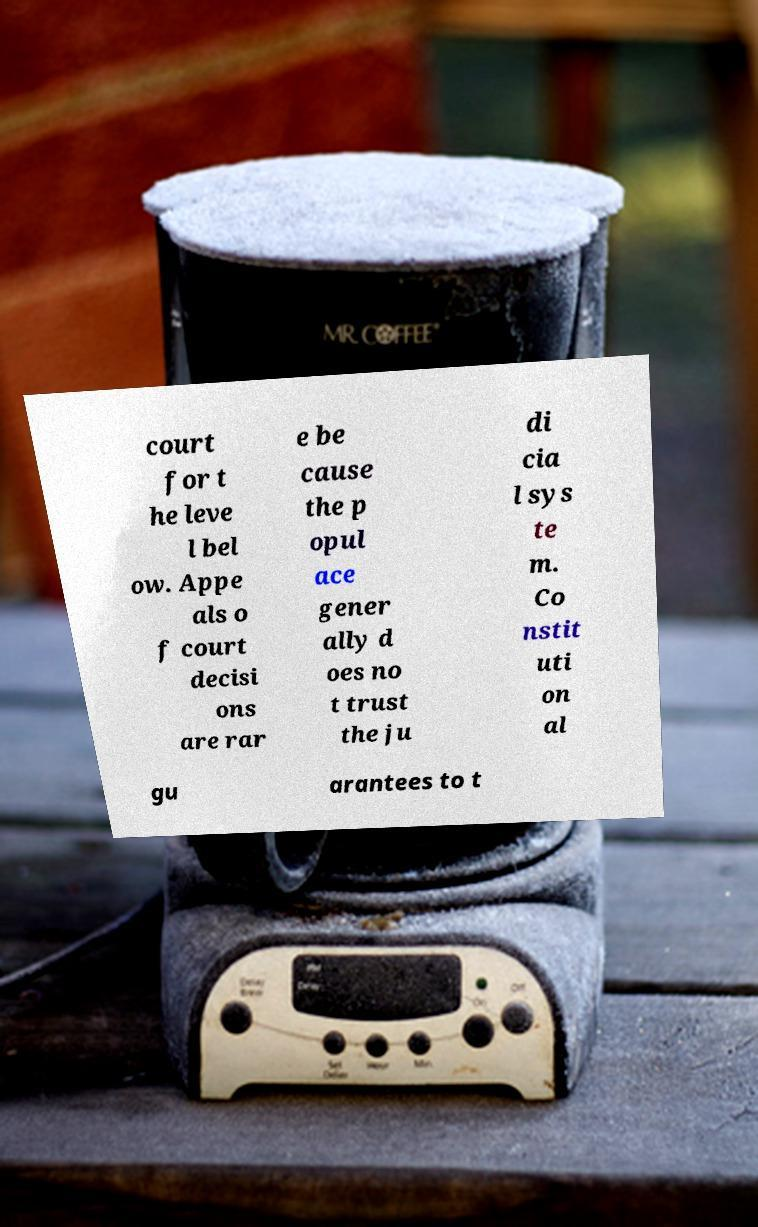Please read and relay the text visible in this image. What does it say? court for t he leve l bel ow. Appe als o f court decisi ons are rar e be cause the p opul ace gener ally d oes no t trust the ju di cia l sys te m. Co nstit uti on al gu arantees to t 